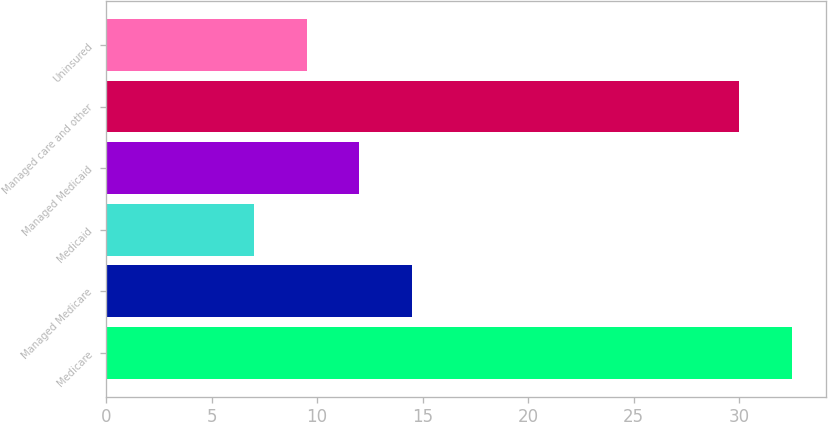Convert chart to OTSL. <chart><loc_0><loc_0><loc_500><loc_500><bar_chart><fcel>Medicare<fcel>Managed Medicare<fcel>Medicaid<fcel>Managed Medicaid<fcel>Managed care and other<fcel>Uninsured<nl><fcel>32.5<fcel>14.5<fcel>7<fcel>12<fcel>30<fcel>9.5<nl></chart> 